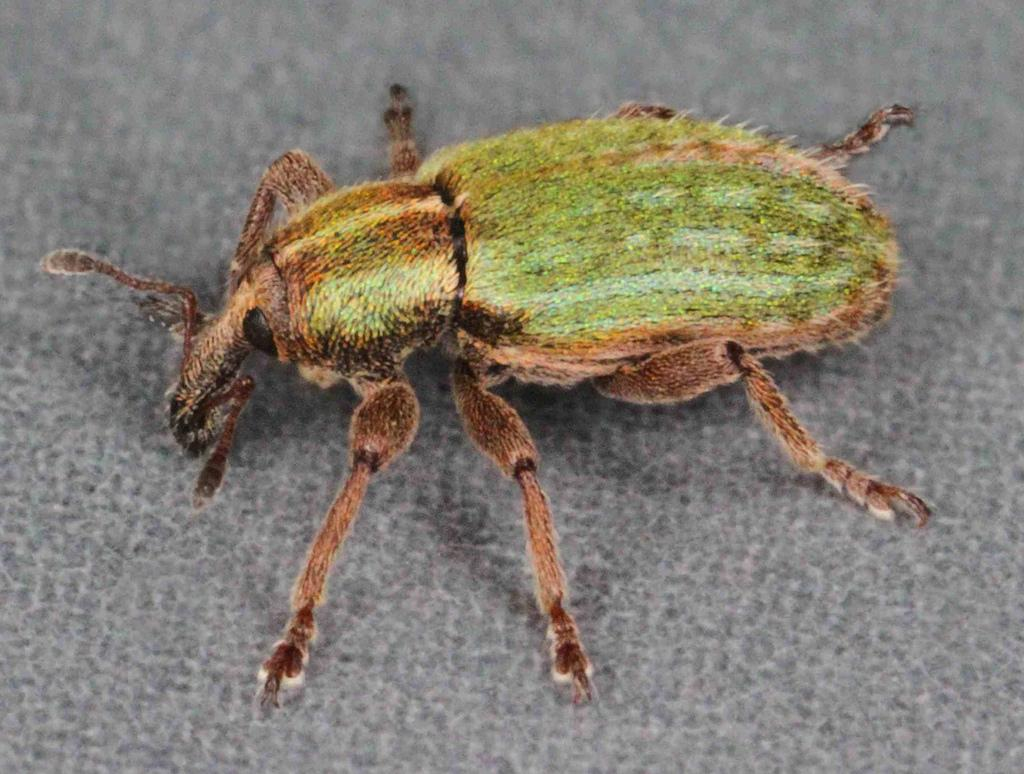What type of creature is in the image? There is an insect in the image. What colors can be seen on the insect? The insect has brown and green colors. What is the color of the surface where the insect is located? The insect is on an ash-colored surface. What time of day is depicted in the image? The time of day is not mentioned or depicted in the image, so it cannot be determined. 